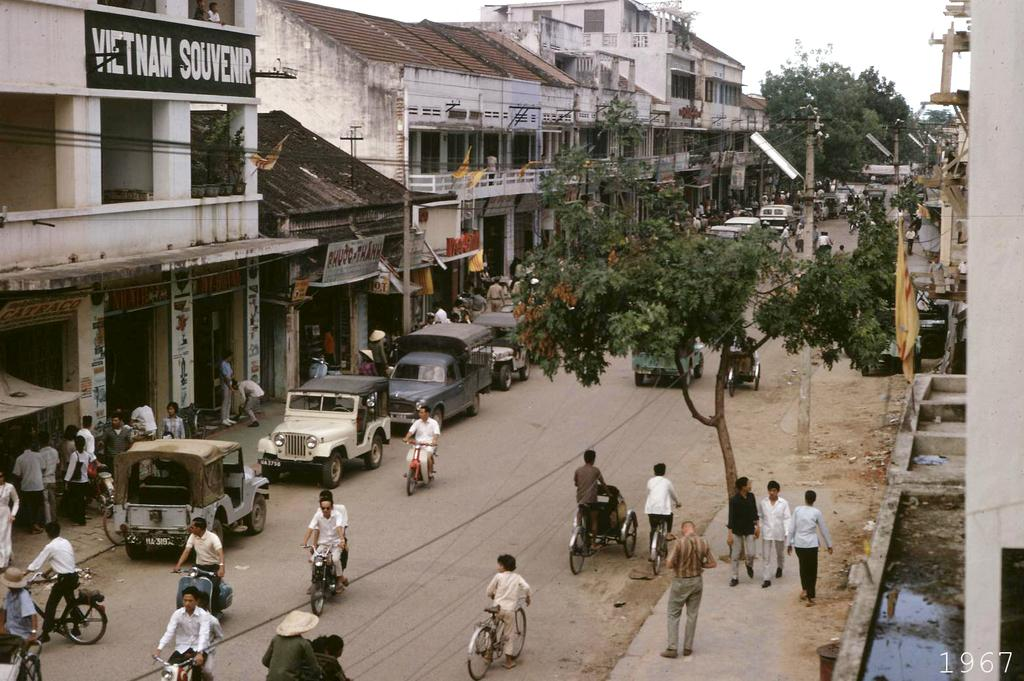<image>
Render a clear and concise summary of the photo. Many people are in the street in front of Vietnam Souvenir. 